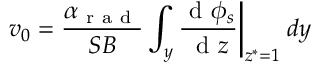<formula> <loc_0><loc_0><loc_500><loc_500>v _ { 0 } = \frac { \alpha _ { r a d } } { S B } \int _ { y } \frac { d \phi _ { s } } { d z } \Big | _ { z ^ { * } = 1 } \, d y</formula> 